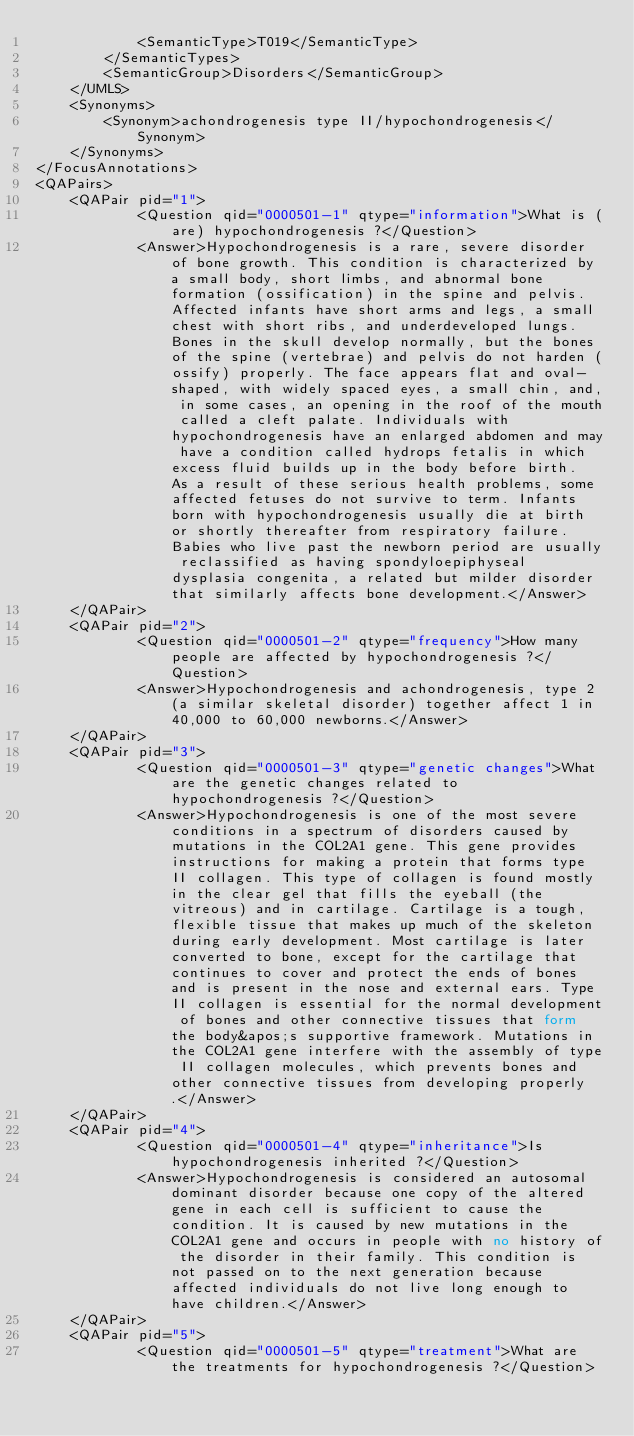Convert code to text. <code><loc_0><loc_0><loc_500><loc_500><_XML_>			<SemanticType>T019</SemanticType>
		</SemanticTypes>
		<SemanticGroup>Disorders</SemanticGroup>
	</UMLS>
	<Synonyms>
		<Synonym>achondrogenesis type II/hypochondrogenesis</Synonym>
	</Synonyms>
</FocusAnnotations>
<QAPairs>
	<QAPair pid="1">
			<Question qid="0000501-1" qtype="information">What is (are) hypochondrogenesis ?</Question>
			<Answer>Hypochondrogenesis is a rare, severe disorder of bone growth. This condition is characterized by a small body, short limbs, and abnormal bone formation (ossification) in the spine and pelvis.  Affected infants have short arms and legs, a small chest with short ribs, and underdeveloped lungs. Bones in the skull develop normally, but the bones of the spine (vertebrae) and pelvis do not harden (ossify) properly. The face appears flat and oval-shaped, with widely spaced eyes, a small chin, and, in some cases, an opening in the roof of the mouth called a cleft palate. Individuals with hypochondrogenesis have an enlarged abdomen and may have a condition called hydrops fetalis in which excess fluid builds up in the body before birth.  As a result of these serious health problems, some affected fetuses do not survive to term. Infants born with hypochondrogenesis usually die at birth or shortly thereafter from respiratory failure. Babies who live past the newborn period are usually reclassified as having spondyloepiphyseal dysplasia congenita, a related but milder disorder that similarly affects bone development.</Answer>
	</QAPair>
	<QAPair pid="2">
			<Question qid="0000501-2" qtype="frequency">How many people are affected by hypochondrogenesis ?</Question>
			<Answer>Hypochondrogenesis and achondrogenesis, type 2 (a similar skeletal disorder) together affect 1 in 40,000 to 60,000 newborns.</Answer>
	</QAPair>
	<QAPair pid="3">
			<Question qid="0000501-3" qtype="genetic changes">What are the genetic changes related to hypochondrogenesis ?</Question>
			<Answer>Hypochondrogenesis is one of the most severe conditions in a spectrum of disorders caused by mutations in the COL2A1 gene. This gene provides instructions for making a protein that forms type II collagen. This type of collagen is found mostly in the clear gel that fills the eyeball (the vitreous) and in cartilage. Cartilage is a tough, flexible tissue that makes up much of the skeleton during early development. Most cartilage is later converted to bone, except for the cartilage that continues to cover and protect the ends of bones and is present in the nose and external ears. Type II collagen is essential for the normal development of bones and other connective tissues that form the body&apos;s supportive framework. Mutations in the COL2A1 gene interfere with the assembly of type II collagen molecules, which prevents bones and other connective tissues from developing properly.</Answer>
	</QAPair>
	<QAPair pid="4">
			<Question qid="0000501-4" qtype="inheritance">Is hypochondrogenesis inherited ?</Question>
			<Answer>Hypochondrogenesis is considered an autosomal dominant disorder because one copy of the altered gene in each cell is sufficient to cause the condition. It is caused by new mutations in the COL2A1 gene and occurs in people with no history of the disorder in their family. This condition is not passed on to the next generation because affected individuals do not live long enough to have children.</Answer>
	</QAPair>
	<QAPair pid="5">
			<Question qid="0000501-5" qtype="treatment">What are the treatments for hypochondrogenesis ?</Question></code> 